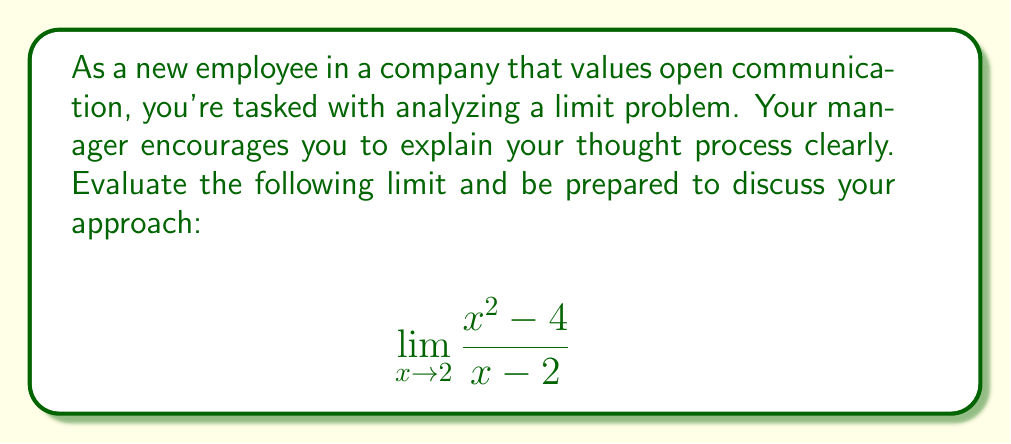Help me with this question. Let's approach this step-by-step:

1) First, we recognize that this is a rational function where both the numerator and denominator approach 0 as $x$ approaches 2. This is an indeterminate form of type $\frac{0}{0}$.

2) We can't directly substitute $x = 2$ as it would lead to division by zero. Instead, we need to simplify the expression.

3) Let's factor the numerator:
   $x^2 - 4 = (x+2)(x-2)$

4) Now our limit looks like this:
   $$\lim_{x \to 2} \frac{(x+2)(x-2)}{x - 2}$$

5) We can cancel the common factor $(x-2)$ in the numerator and denominator:
   $$\lim_{x \to 2} (x+2)$$

6) After cancellation, we can directly substitute $x = 2$:
   $2 + 2 = 4$

7) Therefore, the limit exists and equals 4.

This approach demonstrates the importance of identifying common factors and simplifying before evaluating the limit, showcasing clear problem-solving steps that can be easily communicated to team members or managers.
Answer: $4$ 